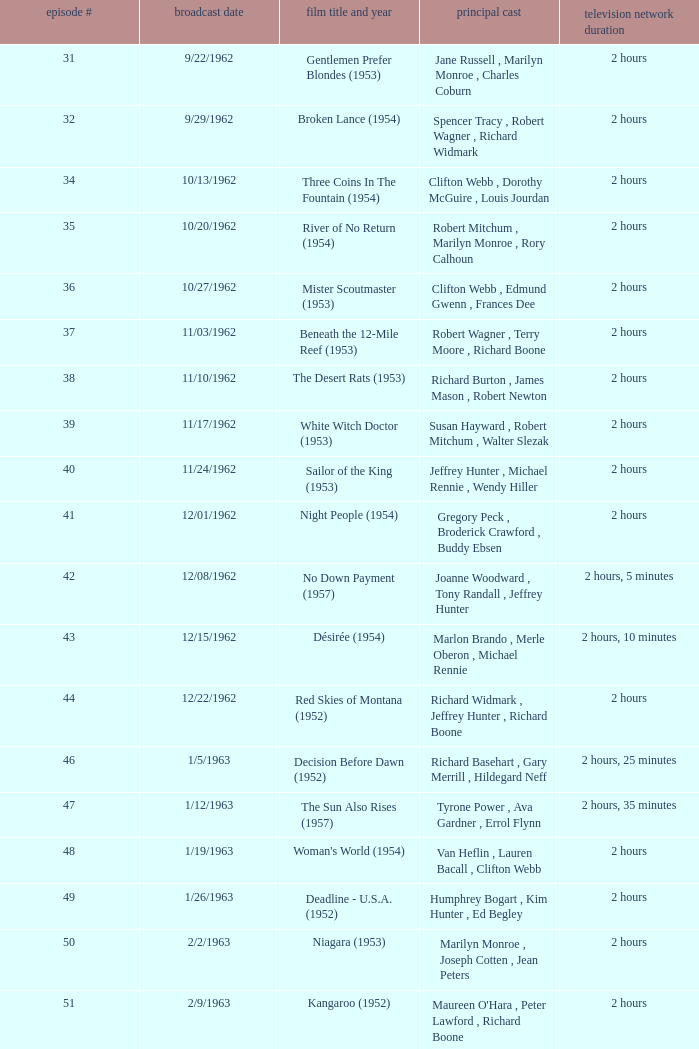What movie did dana wynter , mel ferrer , theodore bikel star in? Fraulein (1958). 